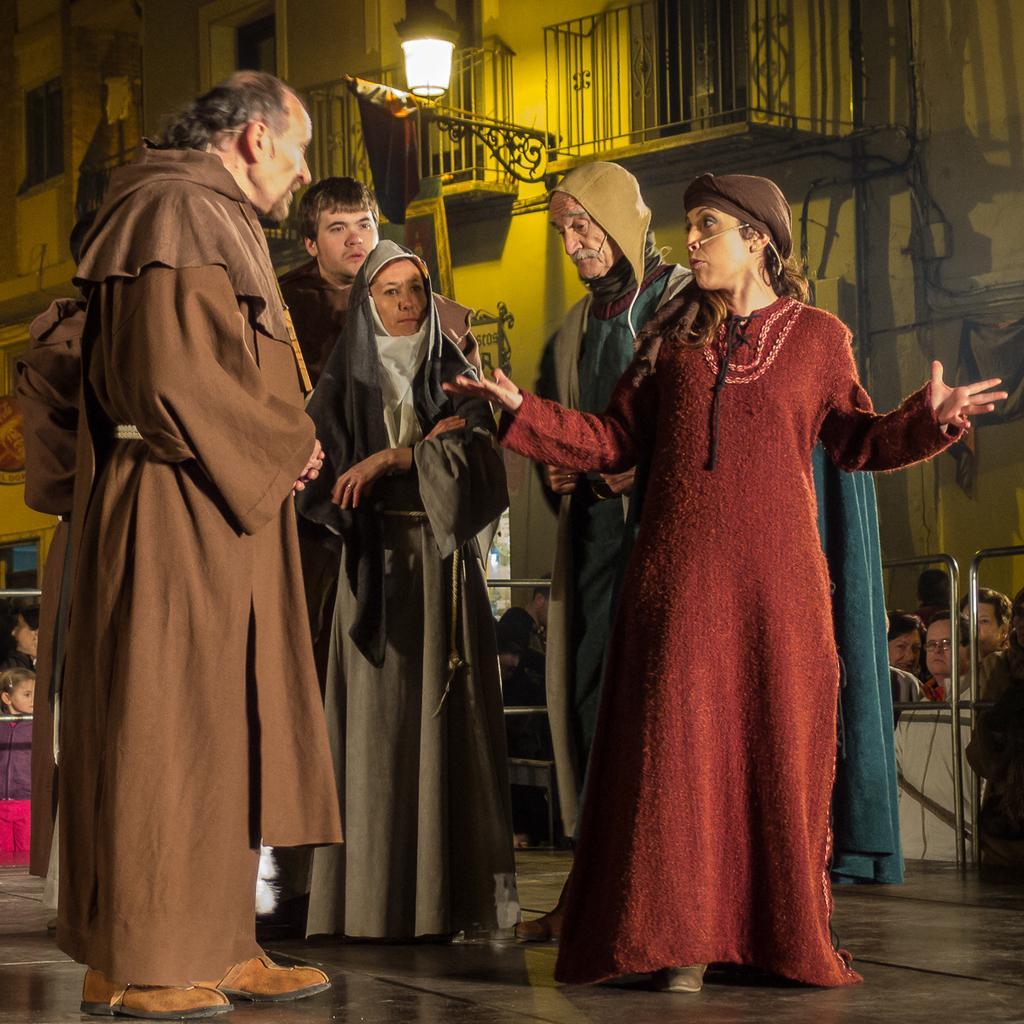How would you summarize this image in a sentence or two? In this picture, there are people wearing ancient costumes. Among them, there are two woman and remaining are men. At the bottom left and right, there are people. On the top, there is a building with hand-grill and light. 